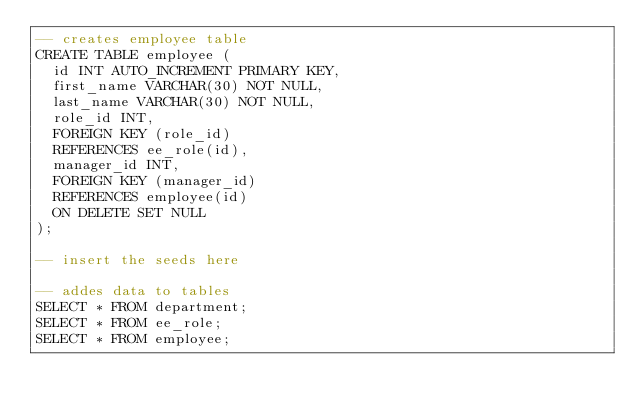Convert code to text. <code><loc_0><loc_0><loc_500><loc_500><_SQL_>-- creates employee table
CREATE TABLE employee (
	id INT AUTO_INCREMENT PRIMARY KEY,
	first_name VARCHAR(30) NOT NULL,
	last_name VARCHAR(30) NOT NULL,
	role_id INT,
	FOREIGN KEY (role_id)
	REFERENCES ee_role(id),
	manager_id INT,
	FOREIGN KEY (manager_id)
	REFERENCES employee(id)
	ON DELETE SET NULL
);

-- insert the seeds here

-- addes data to tables
SELECT * FROM department;
SELECT * FROM ee_role;
SELECT * FROM employee;</code> 